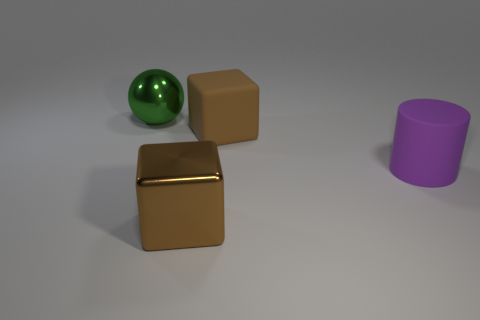The metal object that is in front of the large green metallic sphere left of the big cylinder is what shape?
Your answer should be very brief. Cube. Is there any other thing that is the same shape as the purple object?
Provide a succinct answer. No. Are there the same number of blocks on the left side of the large rubber cube and small cyan metal cubes?
Your response must be concise. No. Do the rubber block and the large thing in front of the big purple matte object have the same color?
Make the answer very short. Yes. There is a object that is both behind the purple matte cylinder and in front of the large green ball; what color is it?
Your answer should be very brief. Brown. What number of brown objects are on the right side of the large metallic thing in front of the green ball?
Offer a terse response. 1. Is there a big purple matte object that has the same shape as the brown metallic object?
Your response must be concise. No. There is a large rubber thing that is in front of the rubber cube; is its shape the same as the brown object in front of the brown rubber block?
Your answer should be very brief. No. How many objects are tiny gray things or green shiny balls?
Your answer should be compact. 1. There is a brown metallic object that is the same shape as the big brown matte thing; what is its size?
Offer a terse response. Large. 